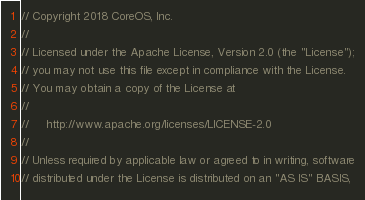<code> <loc_0><loc_0><loc_500><loc_500><_Go_>// Copyright 2018 CoreOS, Inc.
//
// Licensed under the Apache License, Version 2.0 (the "License");
// you may not use this file except in compliance with the License.
// You may obtain a copy of the License at
//
//     http://www.apache.org/licenses/LICENSE-2.0
//
// Unless required by applicable law or agreed to in writing, software
// distributed under the License is distributed on an "AS IS" BASIS,</code> 